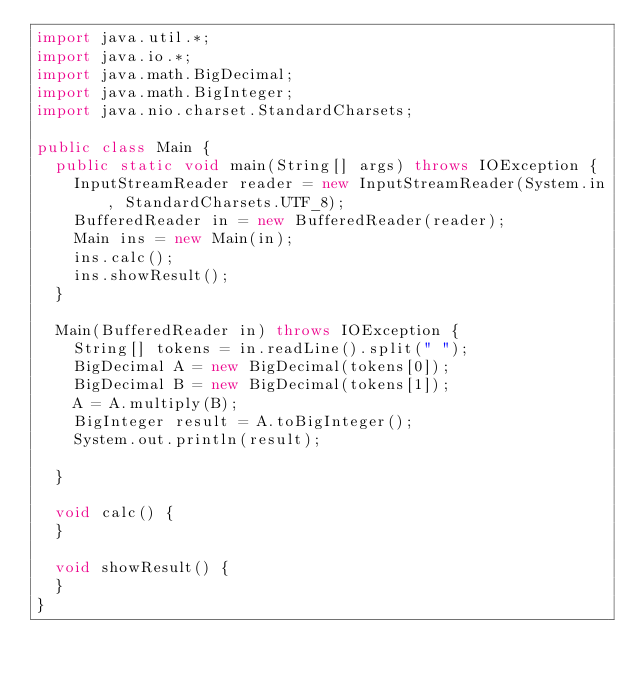Convert code to text. <code><loc_0><loc_0><loc_500><loc_500><_Java_>import java.util.*;
import java.io.*;
import java.math.BigDecimal;
import java.math.BigInteger;
import java.nio.charset.StandardCharsets;

public class Main {
	public static void main(String[] args) throws IOException {
		InputStreamReader reader = new InputStreamReader(System.in, StandardCharsets.UTF_8);
		BufferedReader in = new BufferedReader(reader);
		Main ins = new Main(in);
		ins.calc();
		ins.showResult();
	}

	Main(BufferedReader in) throws IOException {
		String[] tokens = in.readLine().split(" ");
		BigDecimal A = new BigDecimal(tokens[0]);
		BigDecimal B = new BigDecimal(tokens[1]);
		A = A.multiply(B);
		BigInteger result = A.toBigInteger();
		System.out.println(result);

	}

	void calc() {
	}

	void showResult() {
	}
}
</code> 